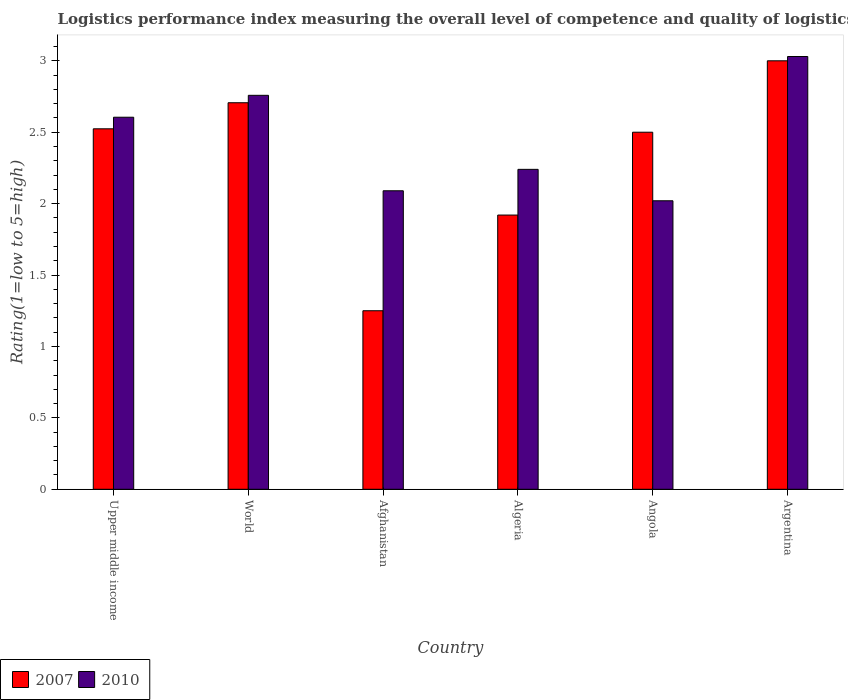How many bars are there on the 4th tick from the left?
Give a very brief answer. 2. What is the label of the 2nd group of bars from the left?
Your answer should be very brief. World. What is the Logistic performance index in 2010 in Algeria?
Provide a short and direct response. 2.24. Across all countries, what is the minimum Logistic performance index in 2010?
Ensure brevity in your answer.  2.02. In which country was the Logistic performance index in 2007 maximum?
Offer a terse response. Argentina. In which country was the Logistic performance index in 2010 minimum?
Offer a terse response. Angola. What is the total Logistic performance index in 2010 in the graph?
Your answer should be very brief. 14.74. What is the difference between the Logistic performance index in 2010 in Argentina and that in World?
Offer a very short reply. 0.27. What is the difference between the Logistic performance index in 2010 in Argentina and the Logistic performance index in 2007 in World?
Provide a short and direct response. 0.32. What is the average Logistic performance index in 2007 per country?
Your response must be concise. 2.32. What is the difference between the Logistic performance index of/in 2007 and Logistic performance index of/in 2010 in Upper middle income?
Provide a succinct answer. -0.08. What is the ratio of the Logistic performance index in 2010 in Argentina to that in Upper middle income?
Provide a short and direct response. 1.16. Is the difference between the Logistic performance index in 2007 in Angola and Argentina greater than the difference between the Logistic performance index in 2010 in Angola and Argentina?
Ensure brevity in your answer.  Yes. What is the difference between the highest and the second highest Logistic performance index in 2007?
Give a very brief answer. -0.29. What is the difference between the highest and the lowest Logistic performance index in 2010?
Your answer should be compact. 1.01. Is the sum of the Logistic performance index in 2010 in Algeria and Upper middle income greater than the maximum Logistic performance index in 2007 across all countries?
Keep it short and to the point. Yes. How many bars are there?
Your answer should be compact. 12. Are all the bars in the graph horizontal?
Make the answer very short. No. Are the values on the major ticks of Y-axis written in scientific E-notation?
Make the answer very short. No. Does the graph contain any zero values?
Ensure brevity in your answer.  No. Does the graph contain grids?
Give a very brief answer. No. How many legend labels are there?
Keep it short and to the point. 2. What is the title of the graph?
Your answer should be very brief. Logistics performance index measuring the overall level of competence and quality of logistics services. Does "2000" appear as one of the legend labels in the graph?
Your response must be concise. No. What is the label or title of the X-axis?
Provide a succinct answer. Country. What is the label or title of the Y-axis?
Provide a short and direct response. Rating(1=low to 5=high). What is the Rating(1=low to 5=high) of 2007 in Upper middle income?
Offer a terse response. 2.52. What is the Rating(1=low to 5=high) in 2010 in Upper middle income?
Keep it short and to the point. 2.6. What is the Rating(1=low to 5=high) of 2007 in World?
Provide a succinct answer. 2.71. What is the Rating(1=low to 5=high) in 2010 in World?
Provide a short and direct response. 2.76. What is the Rating(1=low to 5=high) in 2007 in Afghanistan?
Give a very brief answer. 1.25. What is the Rating(1=low to 5=high) of 2010 in Afghanistan?
Keep it short and to the point. 2.09. What is the Rating(1=low to 5=high) of 2007 in Algeria?
Provide a short and direct response. 1.92. What is the Rating(1=low to 5=high) in 2010 in Algeria?
Your answer should be compact. 2.24. What is the Rating(1=low to 5=high) in 2010 in Angola?
Your answer should be compact. 2.02. What is the Rating(1=low to 5=high) of 2010 in Argentina?
Offer a terse response. 3.03. Across all countries, what is the maximum Rating(1=low to 5=high) in 2007?
Offer a very short reply. 3. Across all countries, what is the maximum Rating(1=low to 5=high) in 2010?
Make the answer very short. 3.03. Across all countries, what is the minimum Rating(1=low to 5=high) in 2007?
Provide a succinct answer. 1.25. Across all countries, what is the minimum Rating(1=low to 5=high) of 2010?
Keep it short and to the point. 2.02. What is the total Rating(1=low to 5=high) of 2007 in the graph?
Ensure brevity in your answer.  13.9. What is the total Rating(1=low to 5=high) of 2010 in the graph?
Provide a succinct answer. 14.74. What is the difference between the Rating(1=low to 5=high) in 2007 in Upper middle income and that in World?
Give a very brief answer. -0.18. What is the difference between the Rating(1=low to 5=high) in 2010 in Upper middle income and that in World?
Provide a succinct answer. -0.15. What is the difference between the Rating(1=low to 5=high) in 2007 in Upper middle income and that in Afghanistan?
Make the answer very short. 1.27. What is the difference between the Rating(1=low to 5=high) of 2010 in Upper middle income and that in Afghanistan?
Ensure brevity in your answer.  0.51. What is the difference between the Rating(1=low to 5=high) of 2007 in Upper middle income and that in Algeria?
Your answer should be compact. 0.6. What is the difference between the Rating(1=low to 5=high) in 2010 in Upper middle income and that in Algeria?
Ensure brevity in your answer.  0.36. What is the difference between the Rating(1=low to 5=high) of 2007 in Upper middle income and that in Angola?
Offer a very short reply. 0.02. What is the difference between the Rating(1=low to 5=high) of 2010 in Upper middle income and that in Angola?
Offer a terse response. 0.58. What is the difference between the Rating(1=low to 5=high) of 2007 in Upper middle income and that in Argentina?
Provide a succinct answer. -0.48. What is the difference between the Rating(1=low to 5=high) of 2010 in Upper middle income and that in Argentina?
Offer a very short reply. -0.43. What is the difference between the Rating(1=low to 5=high) of 2007 in World and that in Afghanistan?
Your answer should be very brief. 1.46. What is the difference between the Rating(1=low to 5=high) in 2010 in World and that in Afghanistan?
Offer a terse response. 0.67. What is the difference between the Rating(1=low to 5=high) in 2007 in World and that in Algeria?
Your answer should be very brief. 0.79. What is the difference between the Rating(1=low to 5=high) in 2010 in World and that in Algeria?
Provide a succinct answer. 0.52. What is the difference between the Rating(1=low to 5=high) of 2007 in World and that in Angola?
Provide a short and direct response. 0.21. What is the difference between the Rating(1=low to 5=high) in 2010 in World and that in Angola?
Make the answer very short. 0.74. What is the difference between the Rating(1=low to 5=high) in 2007 in World and that in Argentina?
Give a very brief answer. -0.29. What is the difference between the Rating(1=low to 5=high) of 2010 in World and that in Argentina?
Provide a succinct answer. -0.27. What is the difference between the Rating(1=low to 5=high) in 2007 in Afghanistan and that in Algeria?
Offer a very short reply. -0.67. What is the difference between the Rating(1=low to 5=high) of 2007 in Afghanistan and that in Angola?
Keep it short and to the point. -1.25. What is the difference between the Rating(1=low to 5=high) in 2010 in Afghanistan and that in Angola?
Your response must be concise. 0.07. What is the difference between the Rating(1=low to 5=high) of 2007 in Afghanistan and that in Argentina?
Your answer should be very brief. -1.75. What is the difference between the Rating(1=low to 5=high) of 2010 in Afghanistan and that in Argentina?
Provide a succinct answer. -0.94. What is the difference between the Rating(1=low to 5=high) of 2007 in Algeria and that in Angola?
Your answer should be very brief. -0.58. What is the difference between the Rating(1=low to 5=high) of 2010 in Algeria and that in Angola?
Give a very brief answer. 0.22. What is the difference between the Rating(1=low to 5=high) in 2007 in Algeria and that in Argentina?
Your answer should be very brief. -1.08. What is the difference between the Rating(1=low to 5=high) in 2010 in Algeria and that in Argentina?
Provide a succinct answer. -0.79. What is the difference between the Rating(1=low to 5=high) in 2010 in Angola and that in Argentina?
Keep it short and to the point. -1.01. What is the difference between the Rating(1=low to 5=high) in 2007 in Upper middle income and the Rating(1=low to 5=high) in 2010 in World?
Ensure brevity in your answer.  -0.23. What is the difference between the Rating(1=low to 5=high) in 2007 in Upper middle income and the Rating(1=low to 5=high) in 2010 in Afghanistan?
Provide a succinct answer. 0.43. What is the difference between the Rating(1=low to 5=high) in 2007 in Upper middle income and the Rating(1=low to 5=high) in 2010 in Algeria?
Provide a short and direct response. 0.28. What is the difference between the Rating(1=low to 5=high) of 2007 in Upper middle income and the Rating(1=low to 5=high) of 2010 in Angola?
Ensure brevity in your answer.  0.5. What is the difference between the Rating(1=low to 5=high) in 2007 in Upper middle income and the Rating(1=low to 5=high) in 2010 in Argentina?
Ensure brevity in your answer.  -0.51. What is the difference between the Rating(1=low to 5=high) in 2007 in World and the Rating(1=low to 5=high) in 2010 in Afghanistan?
Your answer should be compact. 0.62. What is the difference between the Rating(1=low to 5=high) of 2007 in World and the Rating(1=low to 5=high) of 2010 in Algeria?
Provide a short and direct response. 0.47. What is the difference between the Rating(1=low to 5=high) in 2007 in World and the Rating(1=low to 5=high) in 2010 in Angola?
Keep it short and to the point. 0.69. What is the difference between the Rating(1=low to 5=high) in 2007 in World and the Rating(1=low to 5=high) in 2010 in Argentina?
Keep it short and to the point. -0.32. What is the difference between the Rating(1=low to 5=high) of 2007 in Afghanistan and the Rating(1=low to 5=high) of 2010 in Algeria?
Make the answer very short. -0.99. What is the difference between the Rating(1=low to 5=high) in 2007 in Afghanistan and the Rating(1=low to 5=high) in 2010 in Angola?
Offer a very short reply. -0.77. What is the difference between the Rating(1=low to 5=high) of 2007 in Afghanistan and the Rating(1=low to 5=high) of 2010 in Argentina?
Make the answer very short. -1.78. What is the difference between the Rating(1=low to 5=high) in 2007 in Algeria and the Rating(1=low to 5=high) in 2010 in Argentina?
Your answer should be compact. -1.11. What is the difference between the Rating(1=low to 5=high) in 2007 in Angola and the Rating(1=low to 5=high) in 2010 in Argentina?
Offer a terse response. -0.53. What is the average Rating(1=low to 5=high) of 2007 per country?
Provide a short and direct response. 2.32. What is the average Rating(1=low to 5=high) in 2010 per country?
Give a very brief answer. 2.46. What is the difference between the Rating(1=low to 5=high) of 2007 and Rating(1=low to 5=high) of 2010 in Upper middle income?
Your response must be concise. -0.08. What is the difference between the Rating(1=low to 5=high) in 2007 and Rating(1=low to 5=high) in 2010 in World?
Make the answer very short. -0.05. What is the difference between the Rating(1=low to 5=high) of 2007 and Rating(1=low to 5=high) of 2010 in Afghanistan?
Offer a very short reply. -0.84. What is the difference between the Rating(1=low to 5=high) of 2007 and Rating(1=low to 5=high) of 2010 in Algeria?
Keep it short and to the point. -0.32. What is the difference between the Rating(1=low to 5=high) in 2007 and Rating(1=low to 5=high) in 2010 in Angola?
Ensure brevity in your answer.  0.48. What is the difference between the Rating(1=low to 5=high) in 2007 and Rating(1=low to 5=high) in 2010 in Argentina?
Keep it short and to the point. -0.03. What is the ratio of the Rating(1=low to 5=high) in 2007 in Upper middle income to that in World?
Your answer should be compact. 0.93. What is the ratio of the Rating(1=low to 5=high) of 2010 in Upper middle income to that in World?
Keep it short and to the point. 0.94. What is the ratio of the Rating(1=low to 5=high) in 2007 in Upper middle income to that in Afghanistan?
Your answer should be compact. 2.02. What is the ratio of the Rating(1=low to 5=high) of 2010 in Upper middle income to that in Afghanistan?
Provide a succinct answer. 1.25. What is the ratio of the Rating(1=low to 5=high) of 2007 in Upper middle income to that in Algeria?
Your response must be concise. 1.31. What is the ratio of the Rating(1=low to 5=high) of 2010 in Upper middle income to that in Algeria?
Your answer should be compact. 1.16. What is the ratio of the Rating(1=low to 5=high) in 2007 in Upper middle income to that in Angola?
Provide a short and direct response. 1.01. What is the ratio of the Rating(1=low to 5=high) of 2010 in Upper middle income to that in Angola?
Keep it short and to the point. 1.29. What is the ratio of the Rating(1=low to 5=high) of 2007 in Upper middle income to that in Argentina?
Ensure brevity in your answer.  0.84. What is the ratio of the Rating(1=low to 5=high) in 2010 in Upper middle income to that in Argentina?
Your answer should be very brief. 0.86. What is the ratio of the Rating(1=low to 5=high) in 2007 in World to that in Afghanistan?
Keep it short and to the point. 2.17. What is the ratio of the Rating(1=low to 5=high) of 2010 in World to that in Afghanistan?
Your answer should be very brief. 1.32. What is the ratio of the Rating(1=low to 5=high) of 2007 in World to that in Algeria?
Your answer should be very brief. 1.41. What is the ratio of the Rating(1=low to 5=high) in 2010 in World to that in Algeria?
Provide a succinct answer. 1.23. What is the ratio of the Rating(1=low to 5=high) of 2007 in World to that in Angola?
Offer a very short reply. 1.08. What is the ratio of the Rating(1=low to 5=high) in 2010 in World to that in Angola?
Provide a short and direct response. 1.37. What is the ratio of the Rating(1=low to 5=high) of 2007 in World to that in Argentina?
Ensure brevity in your answer.  0.9. What is the ratio of the Rating(1=low to 5=high) of 2010 in World to that in Argentina?
Provide a succinct answer. 0.91. What is the ratio of the Rating(1=low to 5=high) of 2007 in Afghanistan to that in Algeria?
Offer a very short reply. 0.65. What is the ratio of the Rating(1=low to 5=high) of 2010 in Afghanistan to that in Algeria?
Your response must be concise. 0.93. What is the ratio of the Rating(1=low to 5=high) of 2010 in Afghanistan to that in Angola?
Ensure brevity in your answer.  1.03. What is the ratio of the Rating(1=low to 5=high) of 2007 in Afghanistan to that in Argentina?
Keep it short and to the point. 0.42. What is the ratio of the Rating(1=low to 5=high) in 2010 in Afghanistan to that in Argentina?
Provide a short and direct response. 0.69. What is the ratio of the Rating(1=low to 5=high) of 2007 in Algeria to that in Angola?
Provide a succinct answer. 0.77. What is the ratio of the Rating(1=low to 5=high) of 2010 in Algeria to that in Angola?
Provide a succinct answer. 1.11. What is the ratio of the Rating(1=low to 5=high) in 2007 in Algeria to that in Argentina?
Ensure brevity in your answer.  0.64. What is the ratio of the Rating(1=low to 5=high) of 2010 in Algeria to that in Argentina?
Your answer should be compact. 0.74. What is the difference between the highest and the second highest Rating(1=low to 5=high) of 2007?
Offer a terse response. 0.29. What is the difference between the highest and the second highest Rating(1=low to 5=high) in 2010?
Provide a succinct answer. 0.27. What is the difference between the highest and the lowest Rating(1=low to 5=high) of 2007?
Give a very brief answer. 1.75. What is the difference between the highest and the lowest Rating(1=low to 5=high) of 2010?
Offer a very short reply. 1.01. 